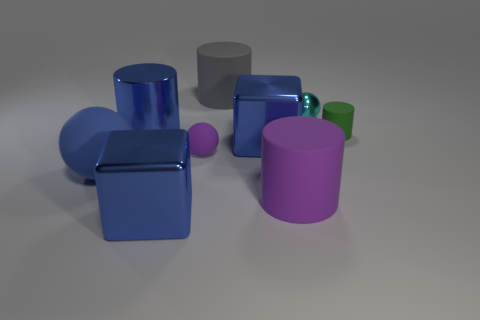Subtract all balls. How many objects are left? 6 Subtract 0 green spheres. How many objects are left? 9 Subtract all large metallic cylinders. Subtract all shiny blocks. How many objects are left? 6 Add 9 small matte balls. How many small matte balls are left? 10 Add 5 small green matte spheres. How many small green matte spheres exist? 5 